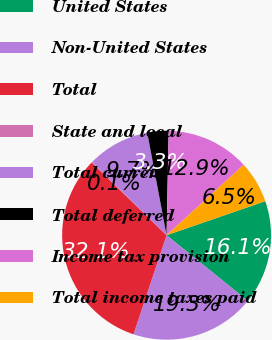<chart> <loc_0><loc_0><loc_500><loc_500><pie_chart><fcel>United States<fcel>Non-United States<fcel>Total<fcel>State and local<fcel>Total current<fcel>Total deferred<fcel>Income tax provision<fcel>Total income taxes paid<nl><fcel>16.11%<fcel>19.31%<fcel>32.14%<fcel>0.07%<fcel>9.69%<fcel>3.28%<fcel>12.9%<fcel>6.49%<nl></chart> 